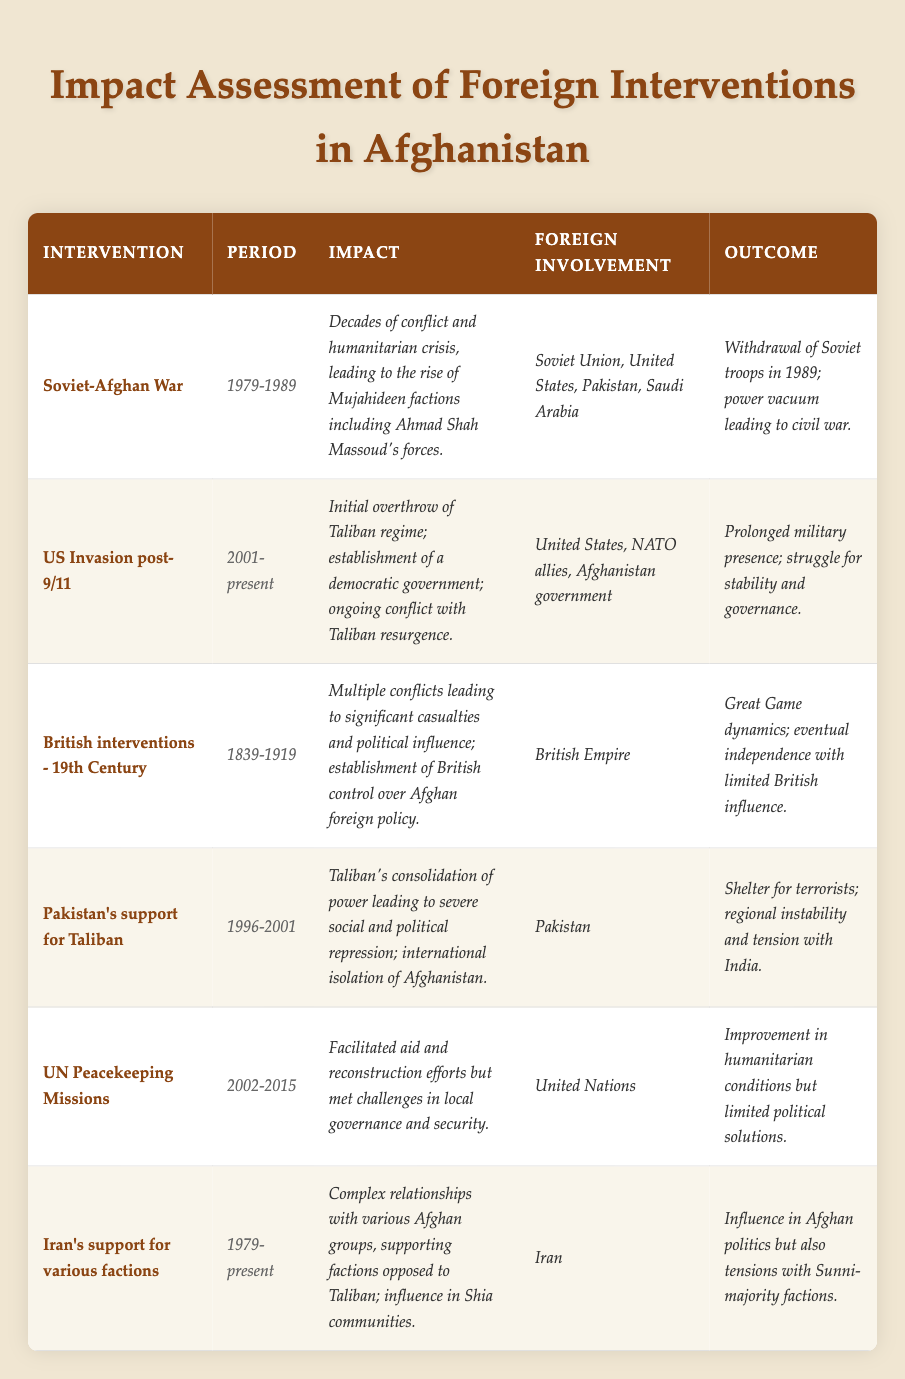What was the period of the Soviet-Afghan War? The table lists the Soviet-Afghan War under the "Period" column as 1979-1989.
Answer: 1979-1989 Which intervention had the most recent outcome reported? Browsing the outcomes in the table, the US Invasion post-9/11 is noted to be ongoing with a present date, while others are historical.
Answer: US Invasion post-9/11 Did Iran have foreign involvement in the support of factions in Afghanistan? The table explicitly states that Iran's support for various factions was a foreign involvement during the period 1979-present.
Answer: Yes List the foreign involvements associated with the Soviet-Afghan War. From the table, the foreign involvements are listed as Soviet Union, United States, Pakistan, and Saudi Arabia.
Answer: Soviet Union, United States, Pakistan, Saudi Arabia What was the outcome of the UN Peacekeeping Missions? The outcome for UN Peacekeeping Missions as per the table indicates an improvement in humanitarian conditions but limited political solutions.
Answer: Improvement in humanitarian conditions but limited political solutions Compare the impact of the UK interventions in the 19th Century with the US invasion post-9/11. The table shows the British interventions led to significant casualties and political influence, while the US invasion resulted in initial regime change but ongoing conflict. The British caused casualties, whereas the US caused ongoing conflict.
Answer: British interventions led to casualties; US invasion caused ongoing conflict What was the main result of Pakistan's support for the Taliban? The table mentions that Pakistan's support led to the Taliban's consolidation of power, severe repression, and international isolation of Afghanistan.
Answer: Consolidation of Taliban power and international isolation How many interventions mentioned lasted beyond the year 2000? The table indicates three interventions: US Invasion post-9/11 (2001-present), UN Peacekeeping Missions (2002-2015), and Iran's support (1979-present) lasted beyond the year 2000.
Answer: Three interventions What are the dynamics mentioned under the British interventions? The table describes the dynamics related to the British interventions as the "Great Game dynamics" with limited British influence after Afghanistan's eventual independence.
Answer: Great Game dynamics; limited British influence Was there any mention of Ahmad Shah Massoud in the table? Upon reviewing the impact of the Soviet-Afghan War, the table specifically notes Ahmad Shah Massoud's forces as part of the Mujahideen factions that rose during that conflict.
Answer: Yes 